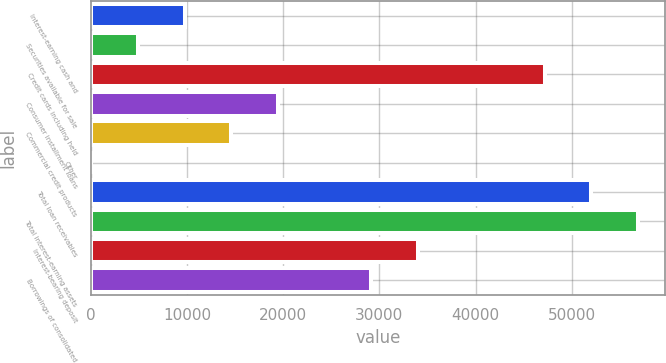Convert chart to OTSL. <chart><loc_0><loc_0><loc_500><loc_500><bar_chart><fcel>Interest-earning cash and<fcel>Securities available for sale<fcel>Credit cards including held<fcel>Consumer installment loans<fcel>Commercial credit products<fcel>Other<fcel>Total loan receivables<fcel>Total interest-earning assets<fcel>Interest-bearing deposit<fcel>Borrowings of consolidated<nl><fcel>9729.4<fcel>4873.7<fcel>47198.7<fcel>19440.8<fcel>14585.1<fcel>18<fcel>52054.4<fcel>56910.1<fcel>34007.9<fcel>29152.2<nl></chart> 